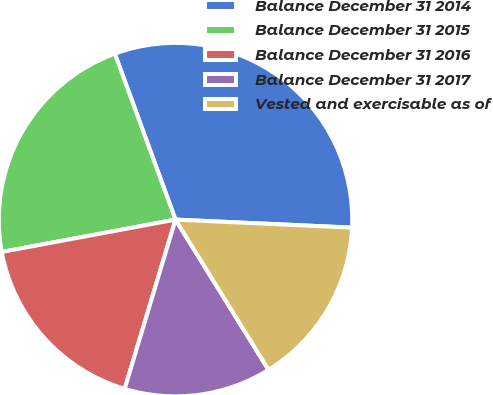<chart> <loc_0><loc_0><loc_500><loc_500><pie_chart><fcel>Balance December 31 2014<fcel>Balance December 31 2015<fcel>Balance December 31 2016<fcel>Balance December 31 2017<fcel>Vested and exercisable as of<nl><fcel>31.3%<fcel>22.35%<fcel>17.43%<fcel>13.47%<fcel>15.45%<nl></chart> 